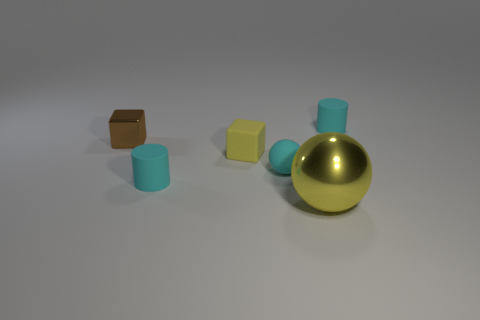Is there anything else that is the same size as the yellow metal object?
Offer a very short reply. No. Is the number of metal things in front of the big thing the same as the number of cyan balls that are behind the rubber cube?
Your response must be concise. Yes. What number of tiny brown shiny blocks are there?
Offer a very short reply. 1. Are there more shiny cubes in front of the small brown object than yellow metal spheres?
Your response must be concise. No. There is a small object that is behind the brown block; what is its material?
Your answer should be very brief. Rubber. There is a tiny metal thing that is the same shape as the yellow matte object; what color is it?
Your response must be concise. Brown. What number of matte blocks are the same color as the metal sphere?
Provide a short and direct response. 1. There is a shiny thing that is behind the cyan ball; does it have the same size as the cylinder that is behind the tiny brown shiny cube?
Ensure brevity in your answer.  Yes. There is a rubber cube; does it have the same size as the cyan thing behind the tiny yellow rubber thing?
Your answer should be compact. Yes. What is the size of the brown block?
Give a very brief answer. Small. 